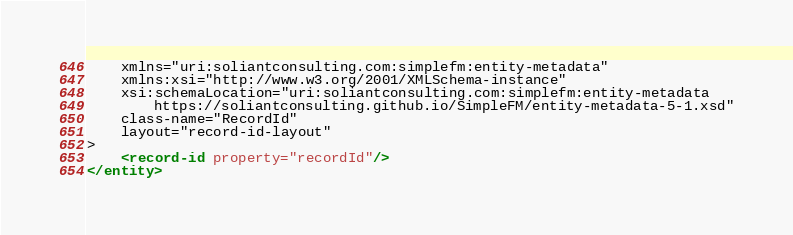<code> <loc_0><loc_0><loc_500><loc_500><_XML_>    xmlns="uri:soliantconsulting.com:simplefm:entity-metadata"
    xmlns:xsi="http://www.w3.org/2001/XMLSchema-instance"
    xsi:schemaLocation="uri:soliantconsulting.com:simplefm:entity-metadata
        https://soliantconsulting.github.io/SimpleFM/entity-metadata-5-1.xsd"
    class-name="RecordId"
    layout="record-id-layout"
>
    <record-id property="recordId"/>
</entity></code> 